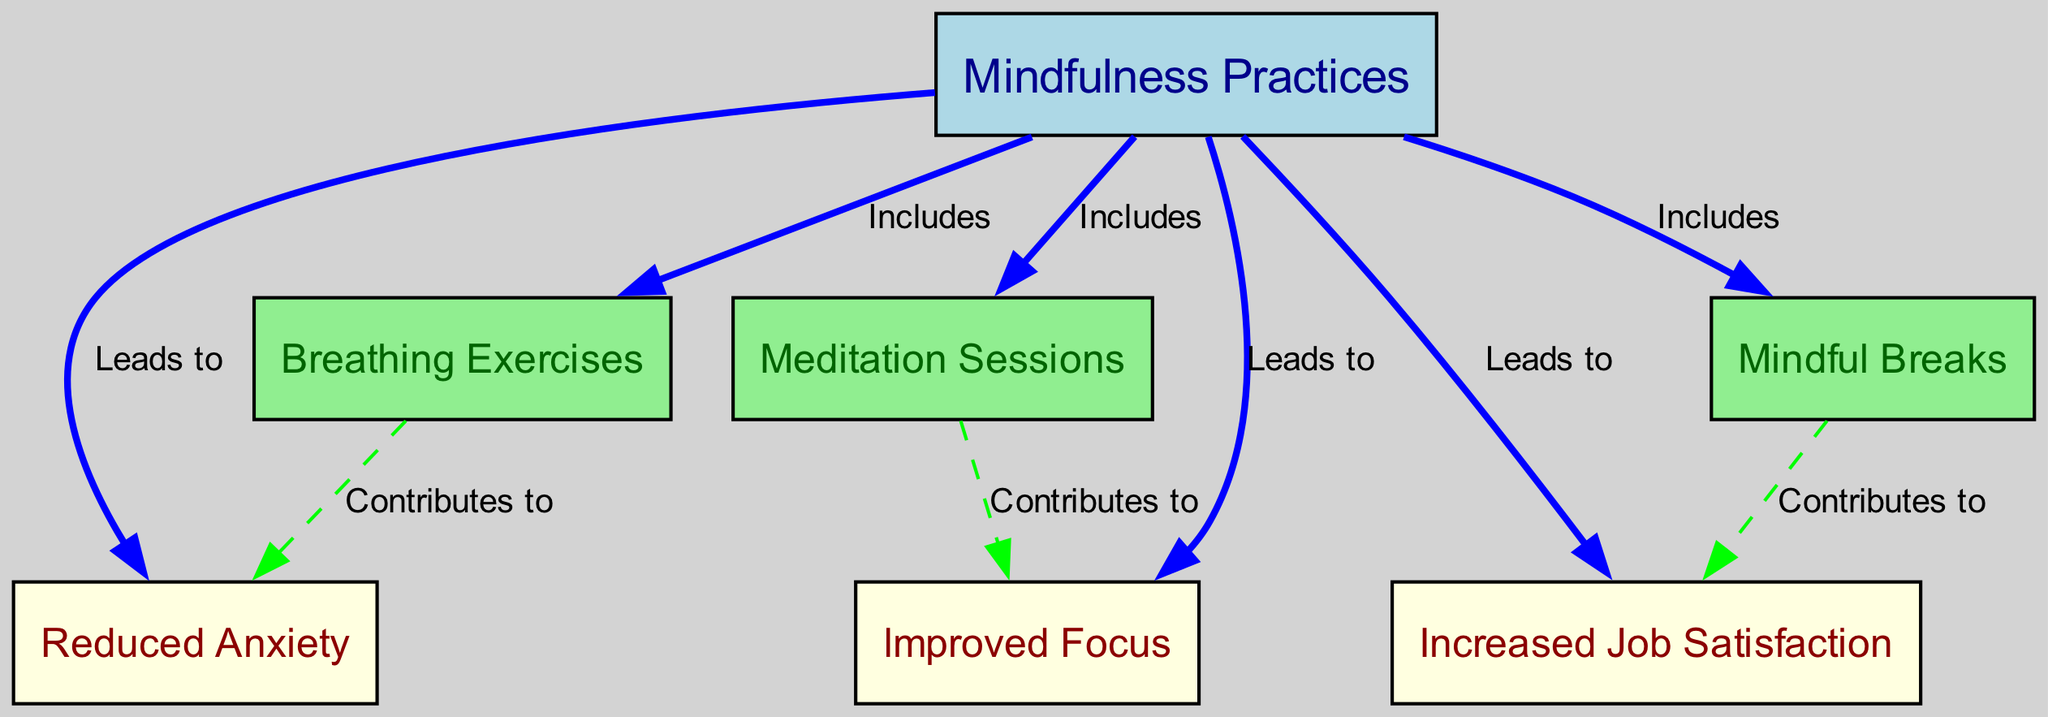What are the three main positive psychological outcomes linked to mindfulness practices? The diagram states that mindfulness practices lead to three main outcomes: reduced anxiety, improved focus, and increased job satisfaction, which are directly labeled in the diagram.
Answer: Reduced Anxiety, Improved Focus, Increased Job Satisfaction How many nodes are present in the diagram? To find the total number of nodes, count each distinct node in the 'nodes' section of the data. There are eight nodes listed: mindfulness practices, reduced anxiety, improved focus, increased job satisfaction, breathing exercises, meditation sessions, and mindful breaks.
Answer: Eight What is the relationship between mindfulness practices and breathing exercises? The diagram shows that mindfulness practices include breathing exercises, as indicated by the "Includes" edge label between these two nodes.
Answer: Includes Which mindfulness practice contributes to improved focus? The diagram specifies a direct connection between meditation sessions and improved focus, with the "Contributes to" edge indicating the role meditation sessions play in this outcome.
Answer: Meditation Sessions How does mindful breaks affect job satisfaction? According to the diagram, mindful breaks contribute to increased job satisfaction. The edge labeled "Contributes to" directly connects mindful breaks with increased job satisfaction in the outcomes shown.
Answer: Contributes to What type of edge connects mindfulness practices to improved focus? The edge that connects mindfulness practices to improved focus is labeled as "Leads to" which indicates a direct influence from mindfulness practices on improved focus in psychological outcomes.
Answer: Leads to Which practice includes breathing exercises? The diagram indicates that breathing exercises fall under the category of mindfulness practices, as denoted by the edge labeled "Includes." This direct connection clarifies that practicing mindfulness encompasses breathing exercises as part of its routine.
Answer: Mindfulness Practices Which node does improved focus directly connect to? The node for improved focus directly connects to meditation sessions, as shown by the edge labeled "Contributes to," establishing a clear relationship between these two elements in the diagram.
Answer: Meditation Sessions 